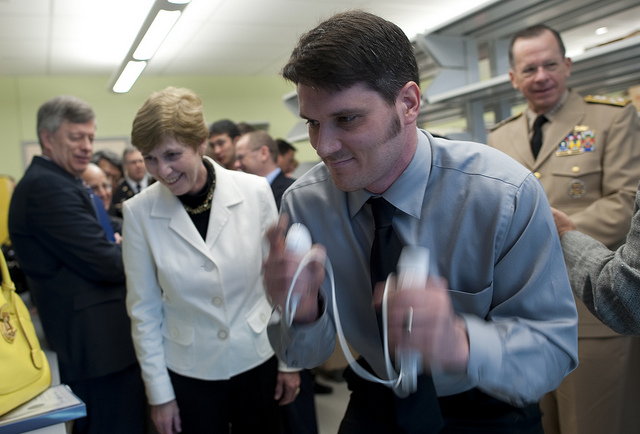What is the atmosphere in the room based on the people's expressions? The atmosphere appears to be positive and engaging. The audience, including the woman in the white jacket, is smiling and seems interested in the performance or explanation given by the person in the foreground.  Can you guess the nature of this event? Based on the attire of the individuals and the decor, it looks like a formal or professional event, possibly related to a demonstration of a technical or scientific nature. 